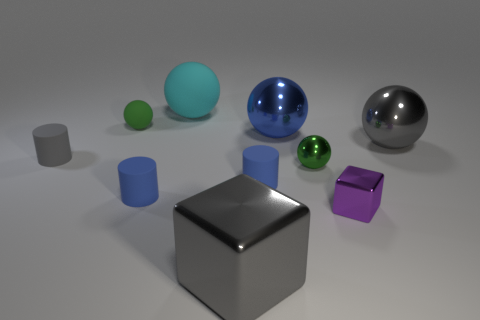Subtract all blocks. How many objects are left? 8 Subtract all large gray cubes. Subtract all tiny blue matte objects. How many objects are left? 7 Add 9 gray cubes. How many gray cubes are left? 10 Add 6 purple objects. How many purple objects exist? 7 Subtract 0 cyan cylinders. How many objects are left? 10 